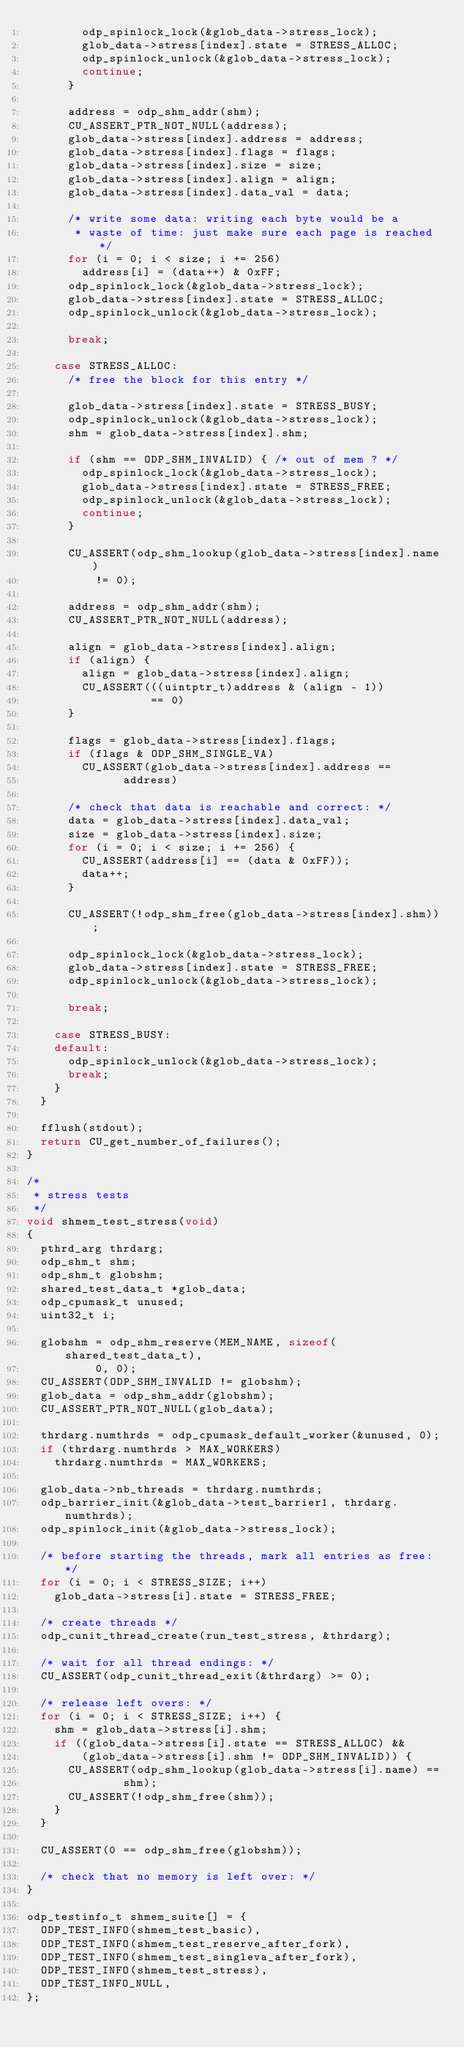<code> <loc_0><loc_0><loc_500><loc_500><_C_>				odp_spinlock_lock(&glob_data->stress_lock);
				glob_data->stress[index].state = STRESS_ALLOC;
				odp_spinlock_unlock(&glob_data->stress_lock);
				continue;
			}

			address = odp_shm_addr(shm);
			CU_ASSERT_PTR_NOT_NULL(address);
			glob_data->stress[index].address = address;
			glob_data->stress[index].flags = flags;
			glob_data->stress[index].size = size;
			glob_data->stress[index].align = align;
			glob_data->stress[index].data_val = data;

			/* write some data: writing each byte would be a
			 * waste of time: just make sure each page is reached */
			for (i = 0; i < size; i += 256)
				address[i] = (data++) & 0xFF;
			odp_spinlock_lock(&glob_data->stress_lock);
			glob_data->stress[index].state = STRESS_ALLOC;
			odp_spinlock_unlock(&glob_data->stress_lock);

			break;

		case STRESS_ALLOC:
			/* free the block for this entry */

			glob_data->stress[index].state = STRESS_BUSY;
			odp_spinlock_unlock(&glob_data->stress_lock);
			shm = glob_data->stress[index].shm;

			if (shm == ODP_SHM_INVALID) { /* out of mem ? */
				odp_spinlock_lock(&glob_data->stress_lock);
				glob_data->stress[index].state = STRESS_FREE;
				odp_spinlock_unlock(&glob_data->stress_lock);
				continue;
			}

			CU_ASSERT(odp_shm_lookup(glob_data->stress[index].name)
				  != 0);

			address = odp_shm_addr(shm);
			CU_ASSERT_PTR_NOT_NULL(address);

			align = glob_data->stress[index].align;
			if (align) {
				align = glob_data->stress[index].align;
				CU_ASSERT(((uintptr_t)address & (align - 1))
									== 0)
			}

			flags = glob_data->stress[index].flags;
			if (flags & ODP_SHM_SINGLE_VA)
				CU_ASSERT(glob_data->stress[index].address ==
							address)

			/* check that data is reachable and correct: */
			data = glob_data->stress[index].data_val;
			size = glob_data->stress[index].size;
			for (i = 0; i < size; i += 256) {
				CU_ASSERT(address[i] == (data & 0xFF));
				data++;
			}

			CU_ASSERT(!odp_shm_free(glob_data->stress[index].shm));

			odp_spinlock_lock(&glob_data->stress_lock);
			glob_data->stress[index].state = STRESS_FREE;
			odp_spinlock_unlock(&glob_data->stress_lock);

			break;

		case STRESS_BUSY:
		default:
			odp_spinlock_unlock(&glob_data->stress_lock);
			break;
		}
	}

	fflush(stdout);
	return CU_get_number_of_failures();
}

/*
 * stress tests
 */
void shmem_test_stress(void)
{
	pthrd_arg thrdarg;
	odp_shm_t shm;
	odp_shm_t globshm;
	shared_test_data_t *glob_data;
	odp_cpumask_t unused;
	uint32_t i;

	globshm = odp_shm_reserve(MEM_NAME, sizeof(shared_test_data_t),
				  0, 0);
	CU_ASSERT(ODP_SHM_INVALID != globshm);
	glob_data = odp_shm_addr(globshm);
	CU_ASSERT_PTR_NOT_NULL(glob_data);

	thrdarg.numthrds = odp_cpumask_default_worker(&unused, 0);
	if (thrdarg.numthrds > MAX_WORKERS)
		thrdarg.numthrds = MAX_WORKERS;

	glob_data->nb_threads = thrdarg.numthrds;
	odp_barrier_init(&glob_data->test_barrier1, thrdarg.numthrds);
	odp_spinlock_init(&glob_data->stress_lock);

	/* before starting the threads, mark all entries as free: */
	for (i = 0; i < STRESS_SIZE; i++)
		glob_data->stress[i].state = STRESS_FREE;

	/* create threads */
	odp_cunit_thread_create(run_test_stress, &thrdarg);

	/* wait for all thread endings: */
	CU_ASSERT(odp_cunit_thread_exit(&thrdarg) >= 0);

	/* release left overs: */
	for (i = 0; i < STRESS_SIZE; i++) {
		shm = glob_data->stress[i].shm;
		if ((glob_data->stress[i].state == STRESS_ALLOC) &&
		    (glob_data->stress[i].shm != ODP_SHM_INVALID)) {
			CU_ASSERT(odp_shm_lookup(glob_data->stress[i].name) ==
							shm);
			CU_ASSERT(!odp_shm_free(shm));
		}
	}

	CU_ASSERT(0 == odp_shm_free(globshm));

	/* check that no memory is left over: */
}

odp_testinfo_t shmem_suite[] = {
	ODP_TEST_INFO(shmem_test_basic),
	ODP_TEST_INFO(shmem_test_reserve_after_fork),
	ODP_TEST_INFO(shmem_test_singleva_after_fork),
	ODP_TEST_INFO(shmem_test_stress),
	ODP_TEST_INFO_NULL,
};
</code> 